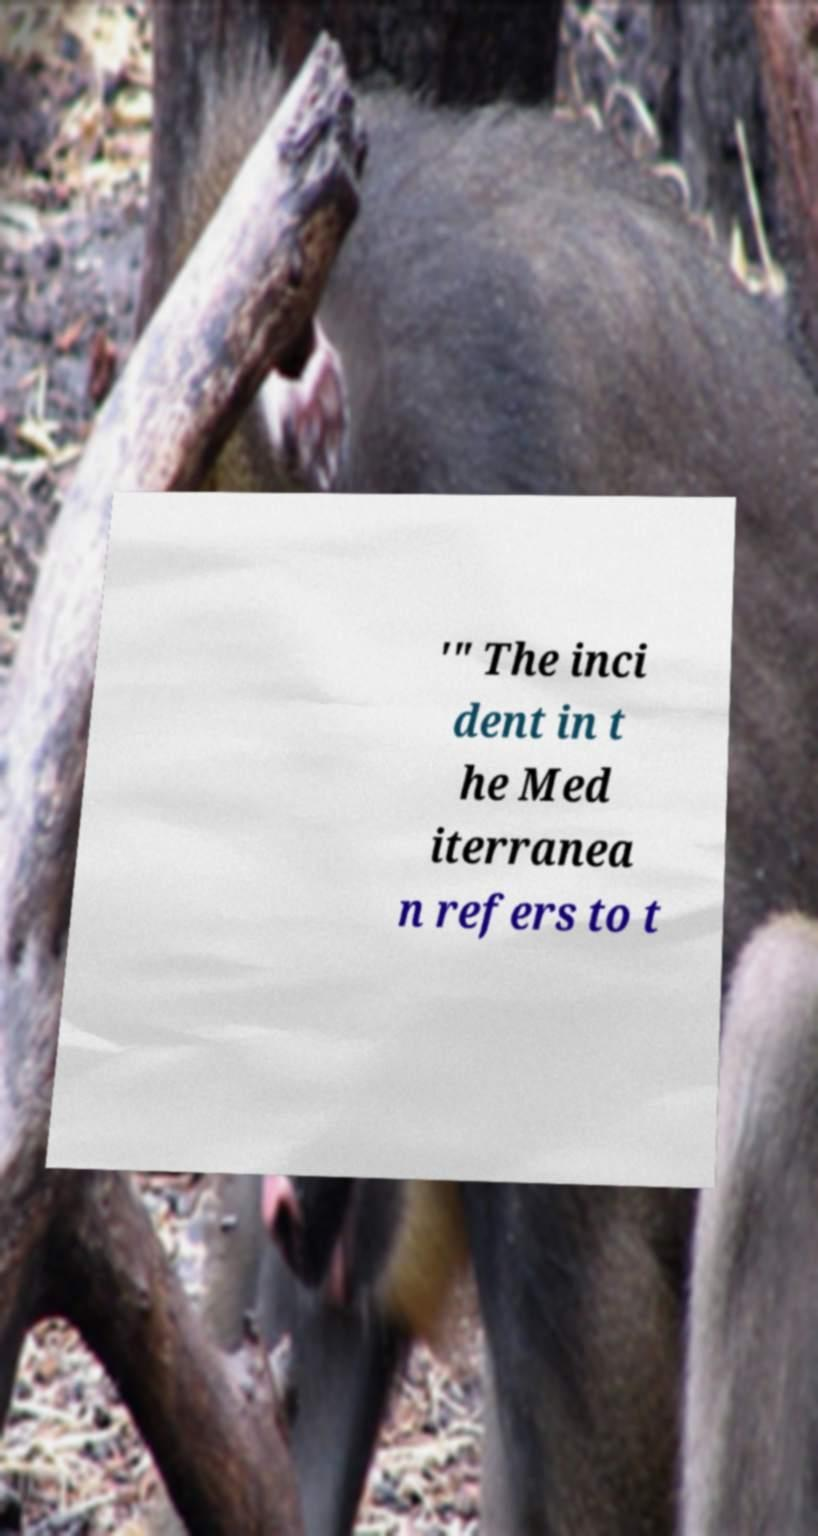For documentation purposes, I need the text within this image transcribed. Could you provide that? '" The inci dent in t he Med iterranea n refers to t 